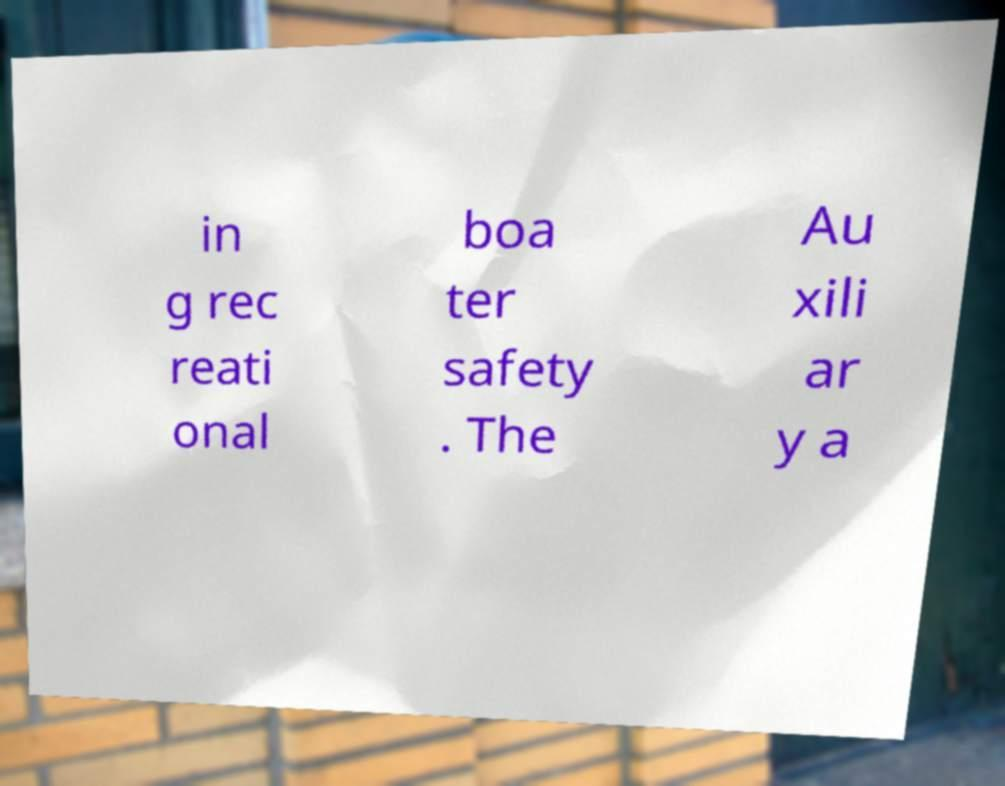Please identify and transcribe the text found in this image. in g rec reati onal boa ter safety . The Au xili ar y a 